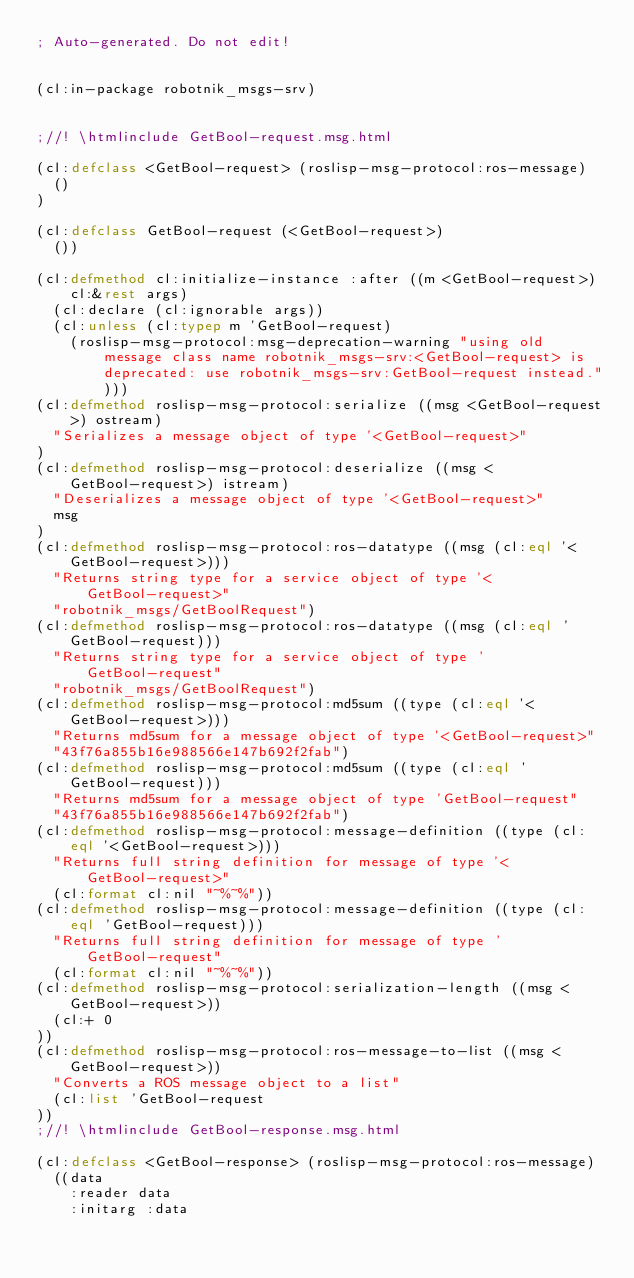Convert code to text. <code><loc_0><loc_0><loc_500><loc_500><_Lisp_>; Auto-generated. Do not edit!


(cl:in-package robotnik_msgs-srv)


;//! \htmlinclude GetBool-request.msg.html

(cl:defclass <GetBool-request> (roslisp-msg-protocol:ros-message)
  ()
)

(cl:defclass GetBool-request (<GetBool-request>)
  ())

(cl:defmethod cl:initialize-instance :after ((m <GetBool-request>) cl:&rest args)
  (cl:declare (cl:ignorable args))
  (cl:unless (cl:typep m 'GetBool-request)
    (roslisp-msg-protocol:msg-deprecation-warning "using old message class name robotnik_msgs-srv:<GetBool-request> is deprecated: use robotnik_msgs-srv:GetBool-request instead.")))
(cl:defmethod roslisp-msg-protocol:serialize ((msg <GetBool-request>) ostream)
  "Serializes a message object of type '<GetBool-request>"
)
(cl:defmethod roslisp-msg-protocol:deserialize ((msg <GetBool-request>) istream)
  "Deserializes a message object of type '<GetBool-request>"
  msg
)
(cl:defmethod roslisp-msg-protocol:ros-datatype ((msg (cl:eql '<GetBool-request>)))
  "Returns string type for a service object of type '<GetBool-request>"
  "robotnik_msgs/GetBoolRequest")
(cl:defmethod roslisp-msg-protocol:ros-datatype ((msg (cl:eql 'GetBool-request)))
  "Returns string type for a service object of type 'GetBool-request"
  "robotnik_msgs/GetBoolRequest")
(cl:defmethod roslisp-msg-protocol:md5sum ((type (cl:eql '<GetBool-request>)))
  "Returns md5sum for a message object of type '<GetBool-request>"
  "43f76a855b16e988566e147b692f2fab")
(cl:defmethod roslisp-msg-protocol:md5sum ((type (cl:eql 'GetBool-request)))
  "Returns md5sum for a message object of type 'GetBool-request"
  "43f76a855b16e988566e147b692f2fab")
(cl:defmethod roslisp-msg-protocol:message-definition ((type (cl:eql '<GetBool-request>)))
  "Returns full string definition for message of type '<GetBool-request>"
  (cl:format cl:nil "~%~%"))
(cl:defmethod roslisp-msg-protocol:message-definition ((type (cl:eql 'GetBool-request)))
  "Returns full string definition for message of type 'GetBool-request"
  (cl:format cl:nil "~%~%"))
(cl:defmethod roslisp-msg-protocol:serialization-length ((msg <GetBool-request>))
  (cl:+ 0
))
(cl:defmethod roslisp-msg-protocol:ros-message-to-list ((msg <GetBool-request>))
  "Converts a ROS message object to a list"
  (cl:list 'GetBool-request
))
;//! \htmlinclude GetBool-response.msg.html

(cl:defclass <GetBool-response> (roslisp-msg-protocol:ros-message)
  ((data
    :reader data
    :initarg :data</code> 